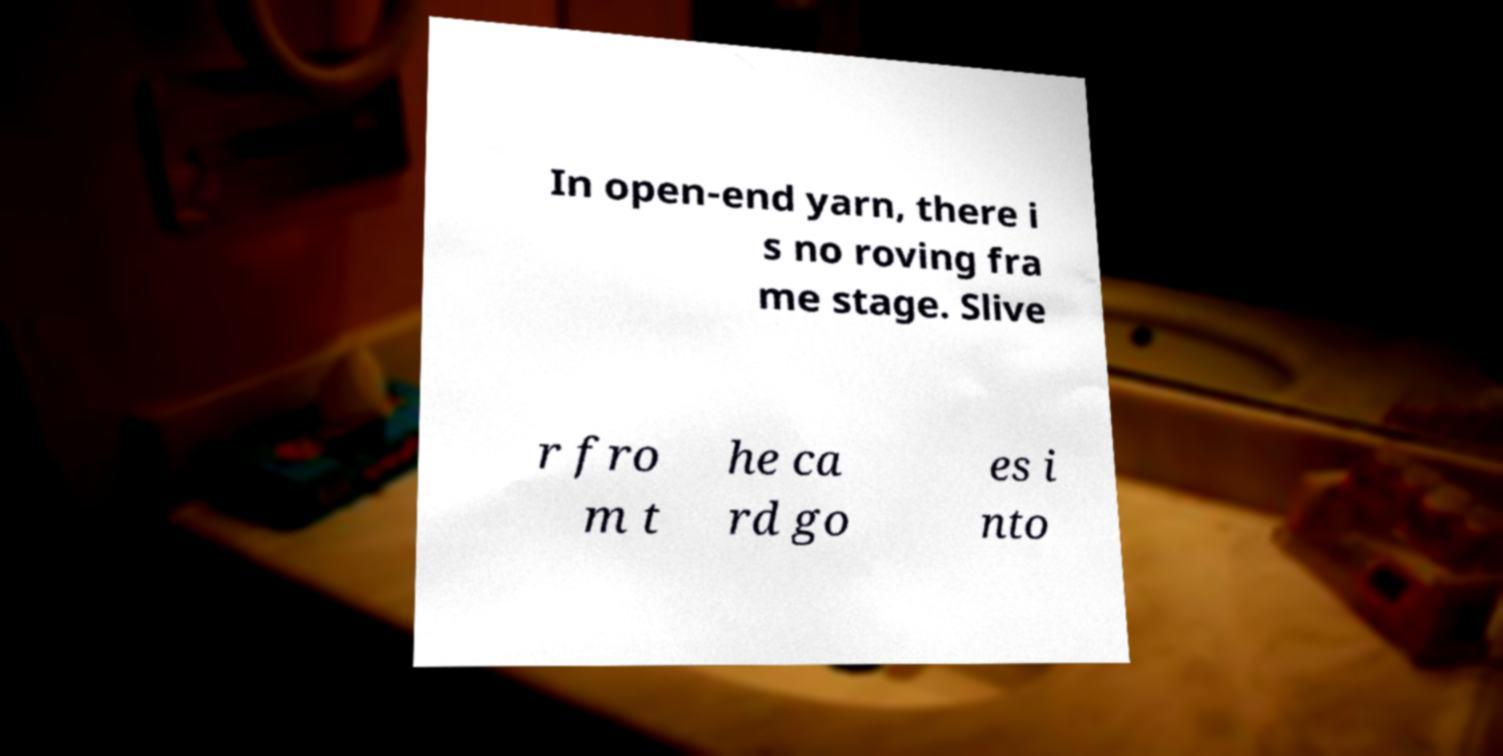Could you assist in decoding the text presented in this image and type it out clearly? In open-end yarn, there i s no roving fra me stage. Slive r fro m t he ca rd go es i nto 